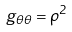Convert formula to latex. <formula><loc_0><loc_0><loc_500><loc_500>g _ { \theta \theta } = \rho ^ { 2 }</formula> 